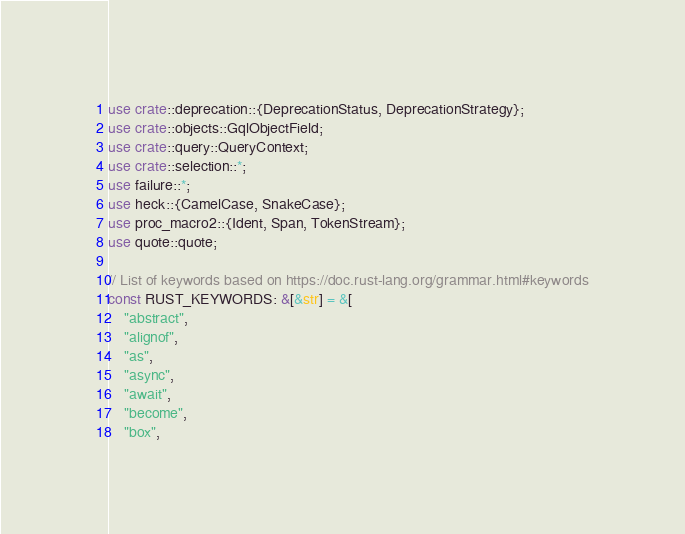Convert code to text. <code><loc_0><loc_0><loc_500><loc_500><_Rust_>use crate::deprecation::{DeprecationStatus, DeprecationStrategy};
use crate::objects::GqlObjectField;
use crate::query::QueryContext;
use crate::selection::*;
use failure::*;
use heck::{CamelCase, SnakeCase};
use proc_macro2::{Ident, Span, TokenStream};
use quote::quote;

// List of keywords based on https://doc.rust-lang.org/grammar.html#keywords
const RUST_KEYWORDS: &[&str] = &[
    "abstract",
    "alignof",
    "as",
    "async",
    "await",
    "become",
    "box",</code> 